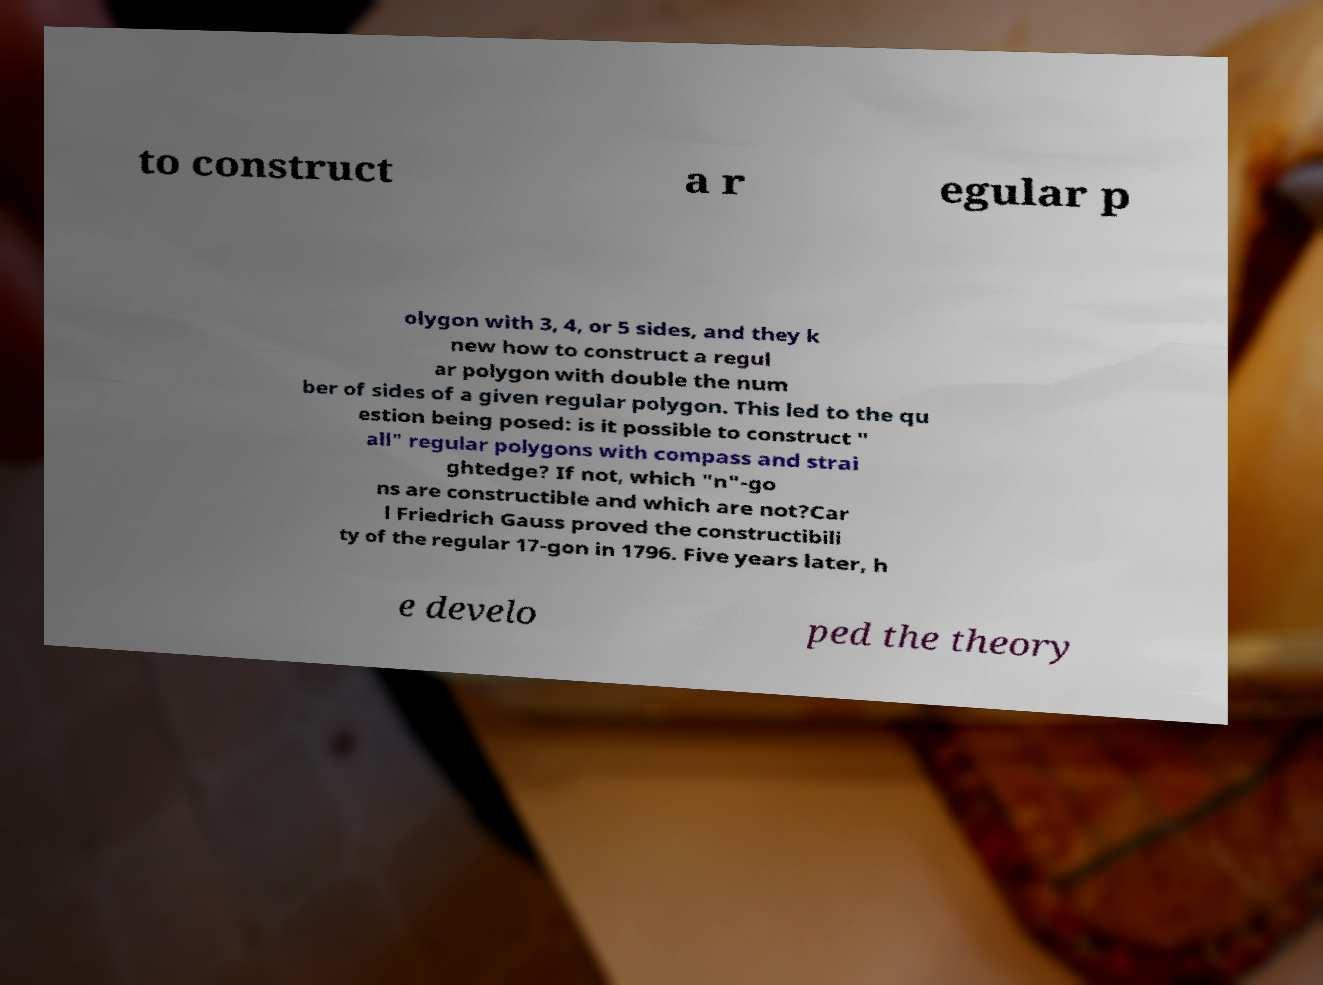Can you read and provide the text displayed in the image?This photo seems to have some interesting text. Can you extract and type it out for me? to construct a r egular p olygon with 3, 4, or 5 sides, and they k new how to construct a regul ar polygon with double the num ber of sides of a given regular polygon. This led to the qu estion being posed: is it possible to construct " all" regular polygons with compass and strai ghtedge? If not, which "n"-go ns are constructible and which are not?Car l Friedrich Gauss proved the constructibili ty of the regular 17-gon in 1796. Five years later, h e develo ped the theory 